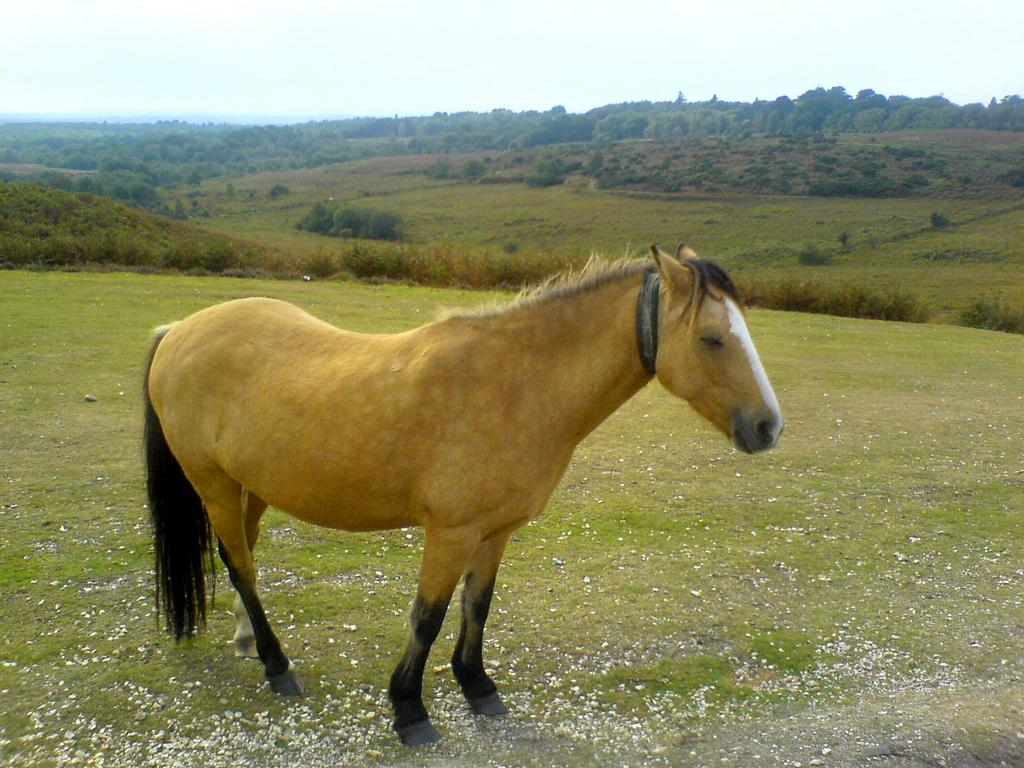What type of animal is in the image? There is a brown horse in the image. What is at the bottom of the image? There is green grass at the bottom of the image. What can be seen in the background of the image? There are plants in the background of the image. What is visible at the top of the image? The sky is visible at the top of the image. How does the horse use scissors to trim the grass in the image? There are no scissors present in the image, and the horse does not trim the grass. 